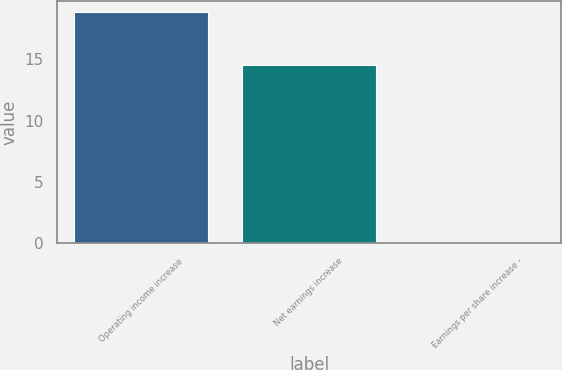Convert chart to OTSL. <chart><loc_0><loc_0><loc_500><loc_500><bar_chart><fcel>Operating income increase<fcel>Net earnings increase<fcel>Earnings per share increase -<nl><fcel>18.8<fcel>14.5<fcel>0.11<nl></chart> 